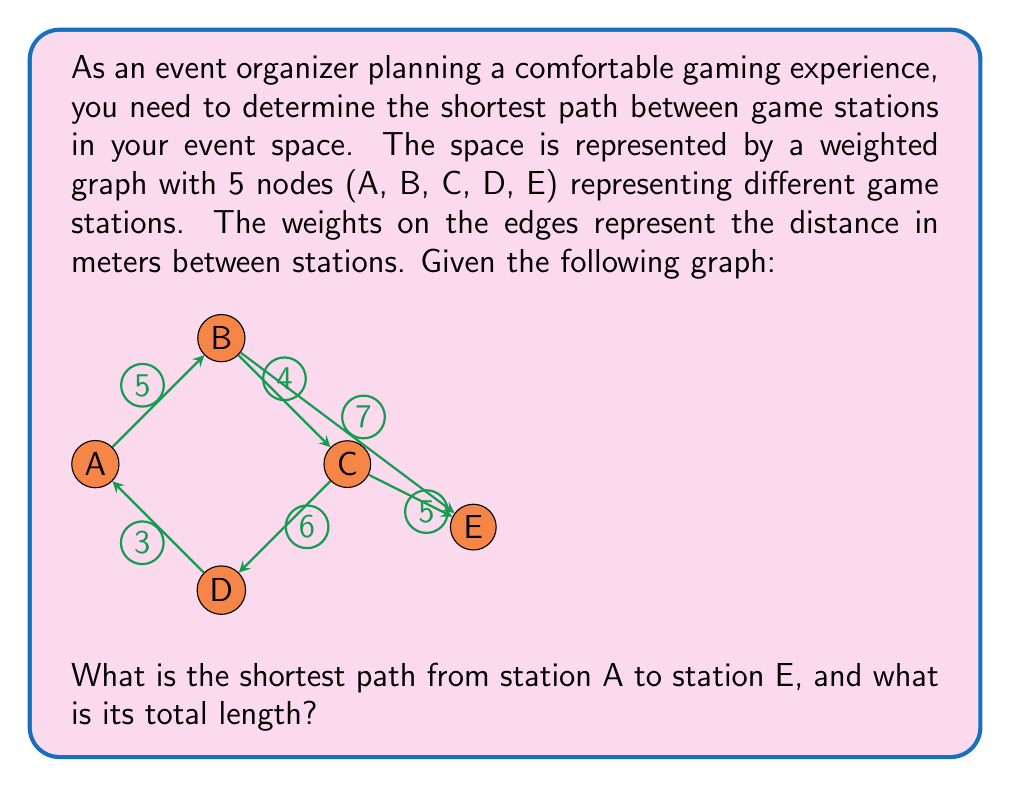Give your solution to this math problem. To solve this problem, we can use Dijkstra's algorithm to find the shortest path from A to E. Let's go through the steps:

1) Initialize:
   - Distance to A = 0
   - Distance to all other nodes = $\infty$
   - Set of unvisited nodes = {A, B, C, D, E}

2) From A:
   - Update distances: B = 5, D = 3
   - Select D (shortest distance)
   - Unvisited = {A, B, C, E}

3) From D:
   - Update distances: C = 9
   - Select B (distance 5)
   - Unvisited = {A, C, E}

4) From B:
   - Update distances: C = min(9, 5+4) = 9, E = 5+7 = 12
   - Select C (distance 9)
   - Unvisited = {A, E}

5) From C:
   - Update distances: E = min(12, 9+5) = 12
   - Select E (distance 12)
   - Unvisited = {A}

The algorithm terminates as we've reached E.

The shortest path is A -> B -> E with a total length of 12 meters.

This path ensures that participants can move comfortably between game stations while minimizing the distance traveled.
Answer: The shortest path from A to E is A -> B -> E, with a total length of 12 meters. 